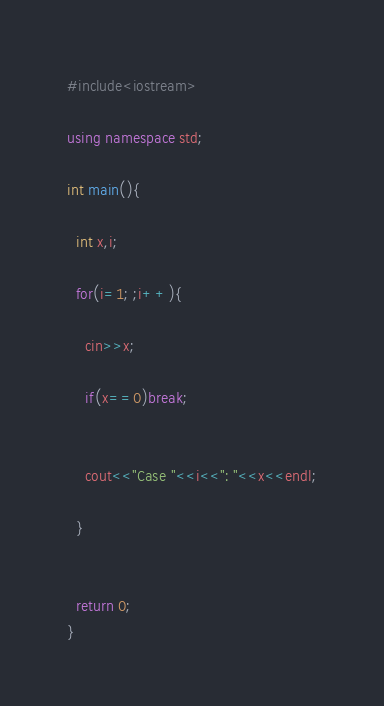<code> <loc_0><loc_0><loc_500><loc_500><_C++_>#include<iostream>

using namespace std;

int main(){

  int x,i;

  for(i=1; ;i++){

    cin>>x;

    if(x==0)break;
  

    cout<<"Case "<<i<<": "<<x<<endl;
  
  }


  return 0;
}</code> 